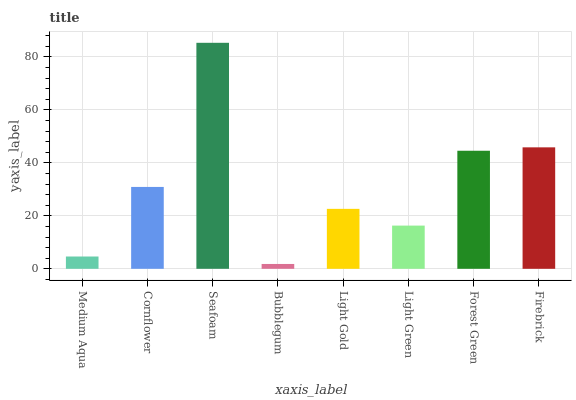Is Bubblegum the minimum?
Answer yes or no. Yes. Is Seafoam the maximum?
Answer yes or no. Yes. Is Cornflower the minimum?
Answer yes or no. No. Is Cornflower the maximum?
Answer yes or no. No. Is Cornflower greater than Medium Aqua?
Answer yes or no. Yes. Is Medium Aqua less than Cornflower?
Answer yes or no. Yes. Is Medium Aqua greater than Cornflower?
Answer yes or no. No. Is Cornflower less than Medium Aqua?
Answer yes or no. No. Is Cornflower the high median?
Answer yes or no. Yes. Is Light Gold the low median?
Answer yes or no. Yes. Is Light Green the high median?
Answer yes or no. No. Is Medium Aqua the low median?
Answer yes or no. No. 